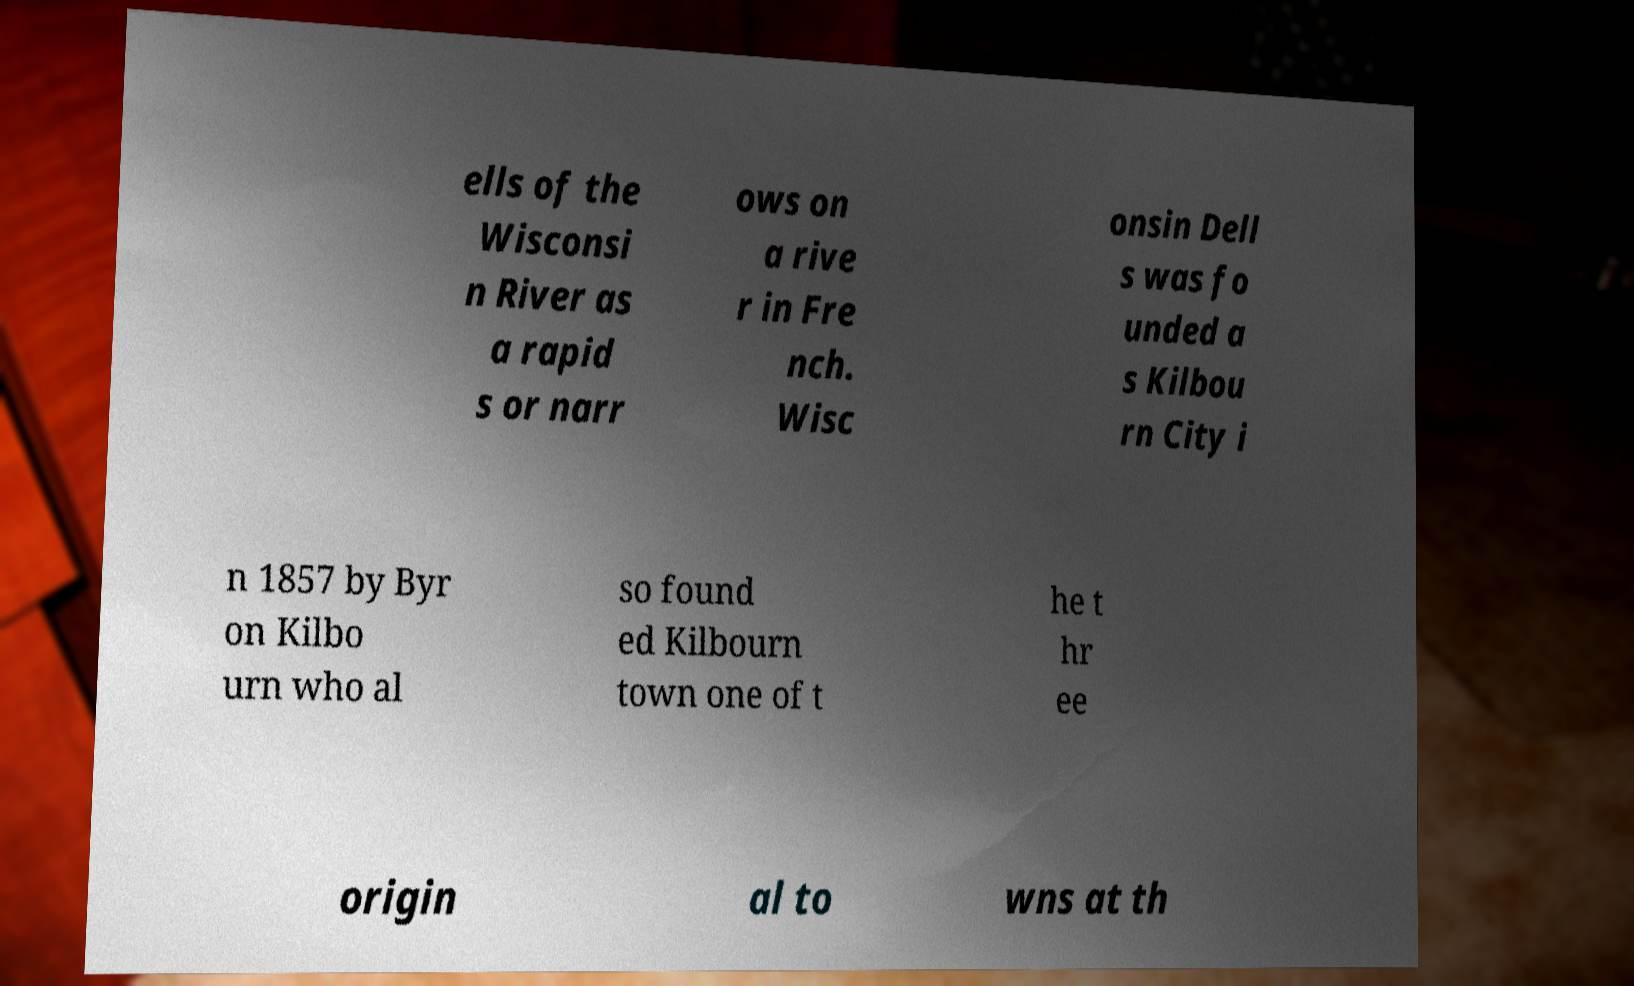Could you extract and type out the text from this image? ells of the Wisconsi n River as a rapid s or narr ows on a rive r in Fre nch. Wisc onsin Dell s was fo unded a s Kilbou rn City i n 1857 by Byr on Kilbo urn who al so found ed Kilbourn town one of t he t hr ee origin al to wns at th 